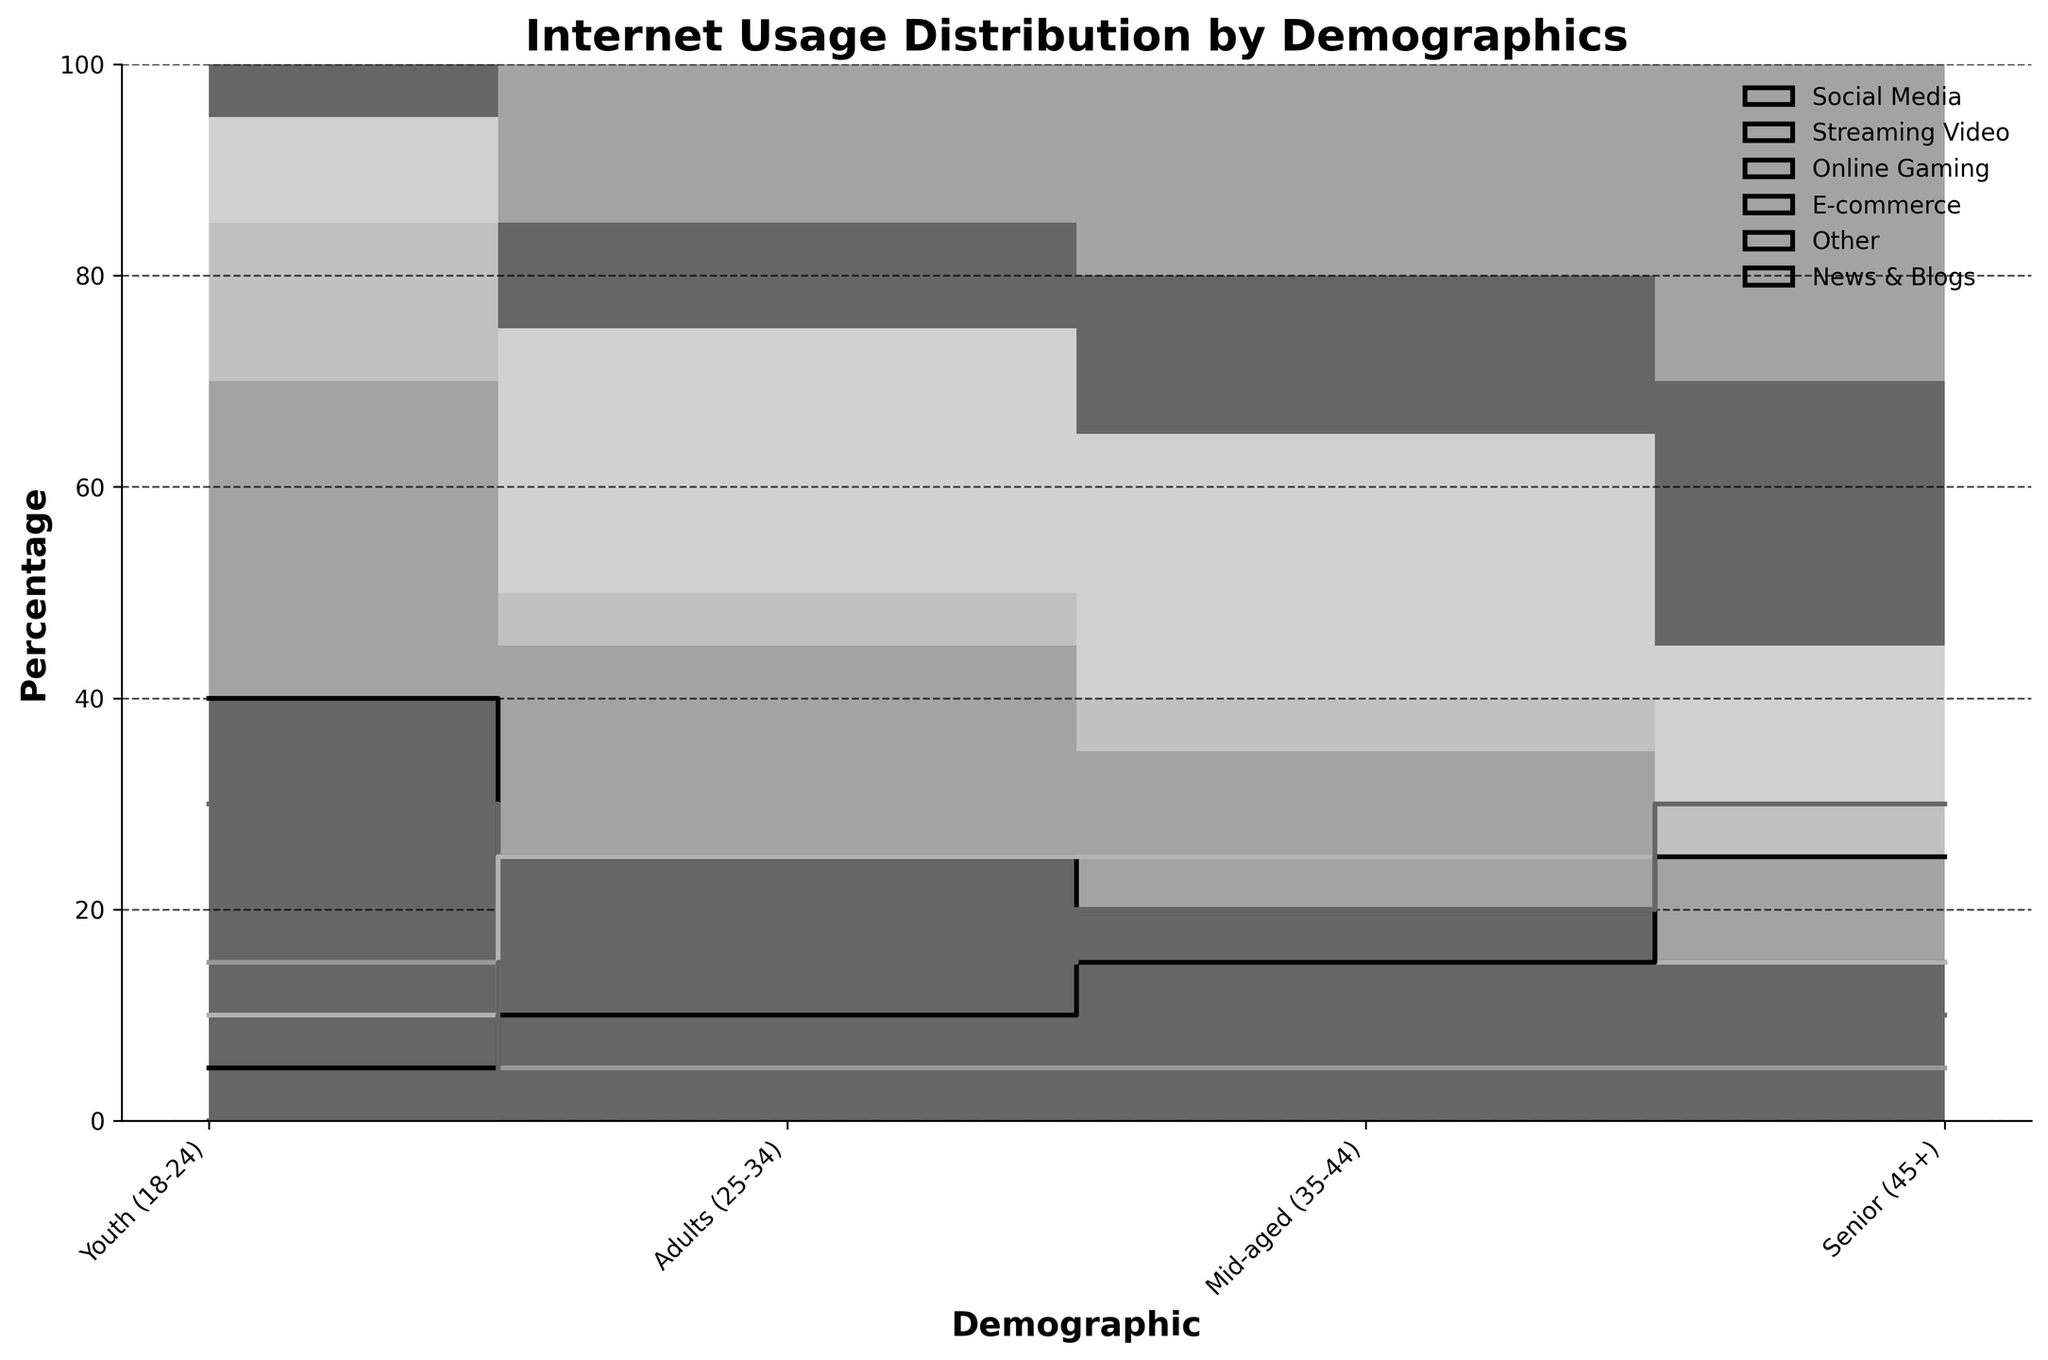What is the title of the figure? The title of the figure is displayed at the top and indicates the main topic of the visualized data. The title helps the viewer understand what the plot is about at a glance.
Answer: Internet Usage Distribution by Demographics Which demographic group has the highest percentage of Social Media usage? To find the demographic group with the highest percentage of Social Media usage, locate the step line corresponding to Social Media and observe which demographic has the highest value on the y-axis.
Answer: Youth (18-24) Compare the percentage of E-commerce usage between Adults (25-34) and Mid-aged (35-44) groups. To compare E-commerce usage, find the values for E-commerce under Adults (25-34) and Mid-aged (35-44). The percentages can be read off the y-axis where the step lines rise.
Answer: Both have 25% What is the overall percentage of Online Gaming usage among all demographics combined? To find the overall percentage, sum the percentage values of Online Gaming across all demographics. The percentages are: 15 (Youth) + 5 (Adults) + 5 (Mid-aged) + 5 (Seniors) = 30.
Answer: 30% Which activity has the lowest percentage within the Mid-aged (35-44) demographic? To determine the activity with the lowest percentage for the Mid-aged group, look at the y-axis values for each activity. Online Gaming has the smallest value.
Answer: Online Gaming Is the percentage of Streaming Video usage higher in the Youth (18-24) or the Senior (45+) demographic? Compare the y-axis values for Streaming Video in Youth (18-24) and Senior (45+). Youth (18-24) has a higher percentage.
Answer: Youth (18-24) What is the difference in the percentage of Social Media usage between the Youth (18-24) and Senior (45+) demographics? To find the difference, subtract the percentage of Social Media usage for Seniors from the percentage for Youth. 40 (Youth) - 15 (Senior) = 25.
Answer: 25% What percentage of Internet activities fall under the "Other" category in the Mid-aged group? The percentage for Other in the Mid-aged group can be directly observed from the y-axis value corresponding to Other for this group.
Answer: 15% Which demographic has the highest percentage usage of News & Blogs? To determine the highest percentage usage of News & Blogs, observe the y-axis percentage values for this activity across all demographics. The highest value corresponds to the Seniors.
Answer: Senior (45+) How does the percentage of Online Gaming compare between Youth and all other demographics combined? Calculate the combined percentages of Online Gaming for Adults, Mid-aged, and Seniors (5+5+5=15) and compare it to the Youth (15). The Youth percentage is equal to the combined percentage of the other groups.
Answer: Equal 